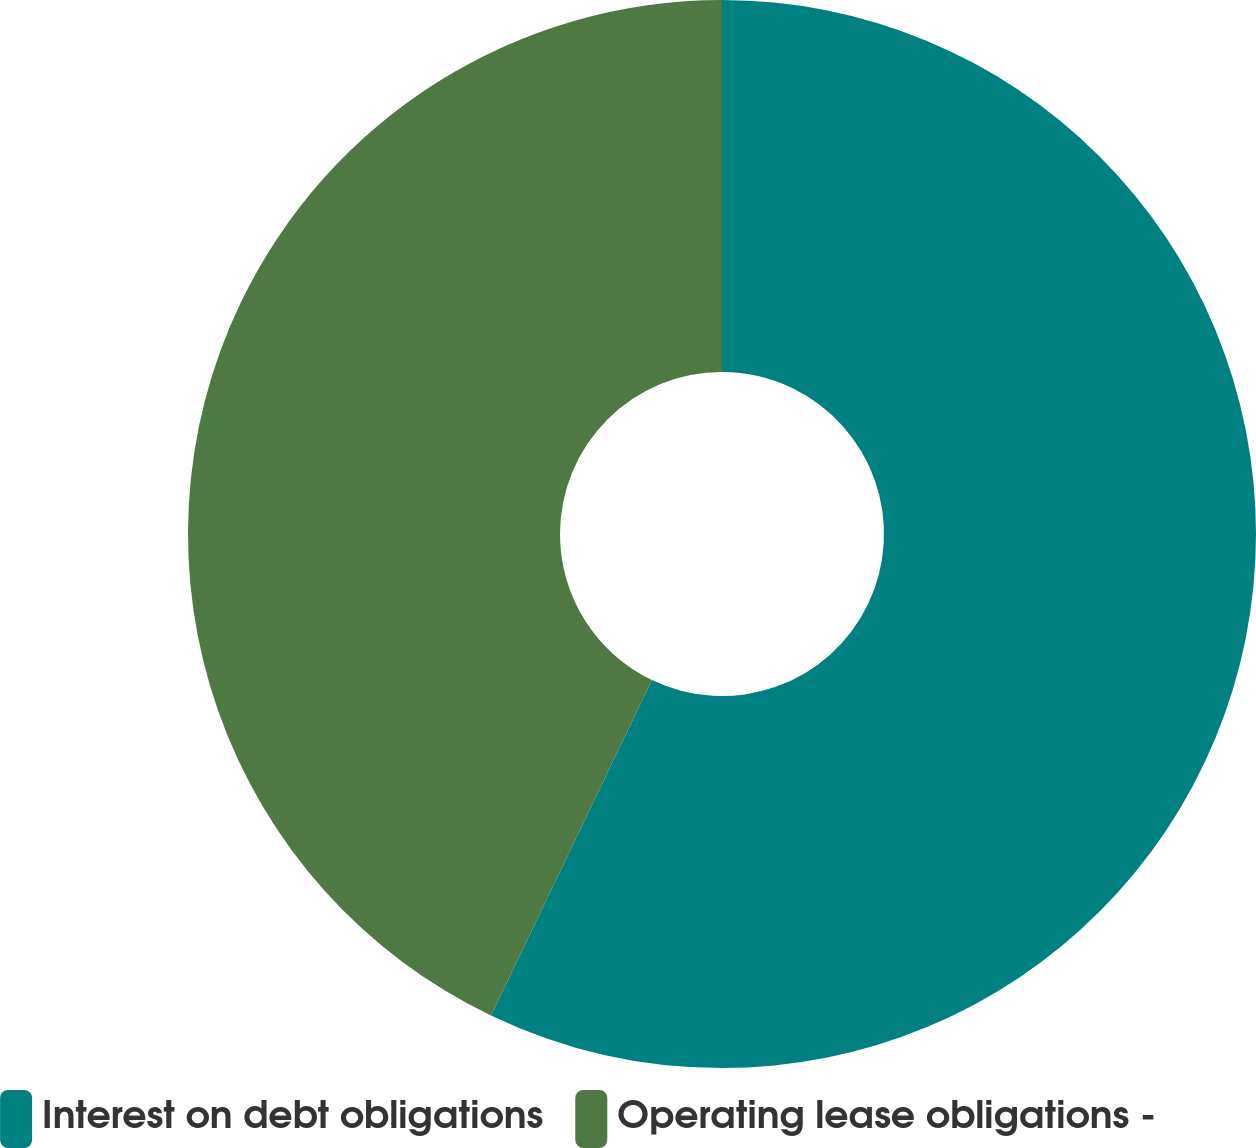Convert chart to OTSL. <chart><loc_0><loc_0><loc_500><loc_500><pie_chart><fcel>Interest on debt obligations<fcel>Operating lease obligations -<nl><fcel>57.12%<fcel>42.88%<nl></chart> 